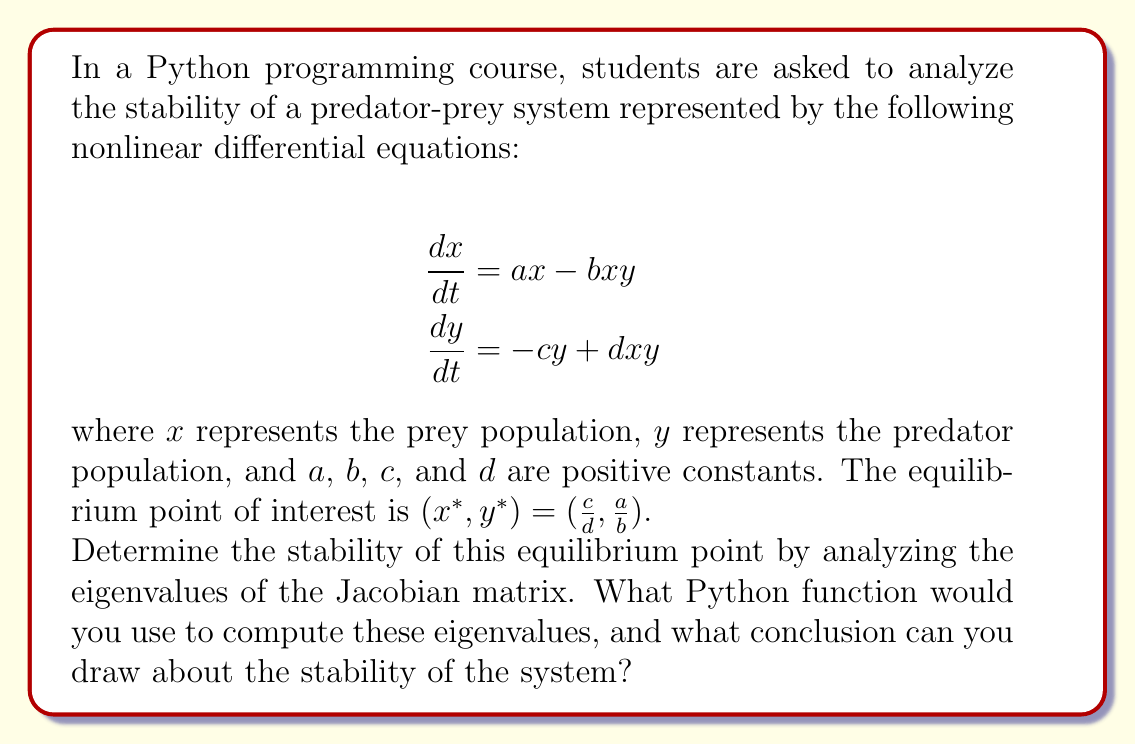Help me with this question. To analyze the stability of the equilibrium point, we need to follow these steps:

1. Calculate the Jacobian matrix at the equilibrium point.
2. Find the eigenvalues of the Jacobian matrix.
3. Interpret the eigenvalues to determine stability.

Step 1: Calculate the Jacobian matrix

The Jacobian matrix is defined as:

$$J = \begin{bmatrix}
\frac{\partial f_1}{\partial x} & \frac{\partial f_1}{\partial y} \\
\frac{\partial f_2}{\partial x} & \frac{\partial f_2}{\partial y}
\end{bmatrix}$$

where $f_1 = ax - bxy$ and $f_2 = -cy + dxy$.

Calculating the partial derivatives:

$$\begin{align}
\frac{\partial f_1}{\partial x} &= a - by \\
\frac{\partial f_1}{\partial y} &= -bx \\
\frac{\partial f_2}{\partial x} &= dy \\
\frac{\partial f_2}{\partial y} &= -c + dx
\end{align}$$

Evaluating at the equilibrium point $(x^*, y^*) = (\frac{c}{d}, \frac{a}{b})$:

$$J = \begin{bmatrix}
a - b(\frac{a}{b}) & -b(\frac{c}{d}) \\
d(\frac{a}{b}) & -c + d(\frac{c}{d})
\end{bmatrix} = \begin{bmatrix}
0 & -\frac{bc}{d} \\
\frac{ad}{b} & 0
\end{bmatrix}$$

Step 2: Find the eigenvalues

To find the eigenvalues, we need to solve the characteristic equation:

$$\det(J - \lambda I) = 0$$

$$\begin{vmatrix}
-\lambda & -\frac{bc}{d} \\
\frac{ad}{b} & -\lambda
\end{vmatrix} = 0$$

$$\lambda^2 + \frac{abc}{d} = 0$$

$$\lambda = \pm i\sqrt{\frac{abc}{d}}$$

Step 3: Interpret the eigenvalues

The eigenvalues are purely imaginary conjugates. This indicates that the equilibrium point is a center, which means the system exhibits periodic behavior around the equilibrium point.

In Python, we can use the numpy.linalg.eigvals() function to compute the eigenvalues of the Jacobian matrix. Here's an example of how to use it:

```python
import numpy as np

def compute_eigenvalues(a, b, c, d):
    J = np.array([[0, -b*c/d], [a*d/b, 0]])
    return np.linalg.eigvals(J)

# Example usage
a, b, c, d = 1, 2, 3, 4
eigenvalues = compute_eigenvalues(a, b, c, d)
print(eigenvalues)
```

This code will return the eigenvalues of the Jacobian matrix, which can be used to determine the stability of the system.
Answer: The stability analysis of the predator-prey system reveals that the equilibrium point $(x^*, y^*) = (\frac{c}{d}, \frac{a}{b})$ is a center. The eigenvalues of the Jacobian matrix are purely imaginary conjugates: $\lambda = \pm i\sqrt{\frac{abc}{d}}$. This indicates that the system exhibits periodic behavior around the equilibrium point, neither converging towards it nor diverging away from it. To compute these eigenvalues in Python, you would use the numpy.linalg.eigvals() function on the Jacobian matrix. 